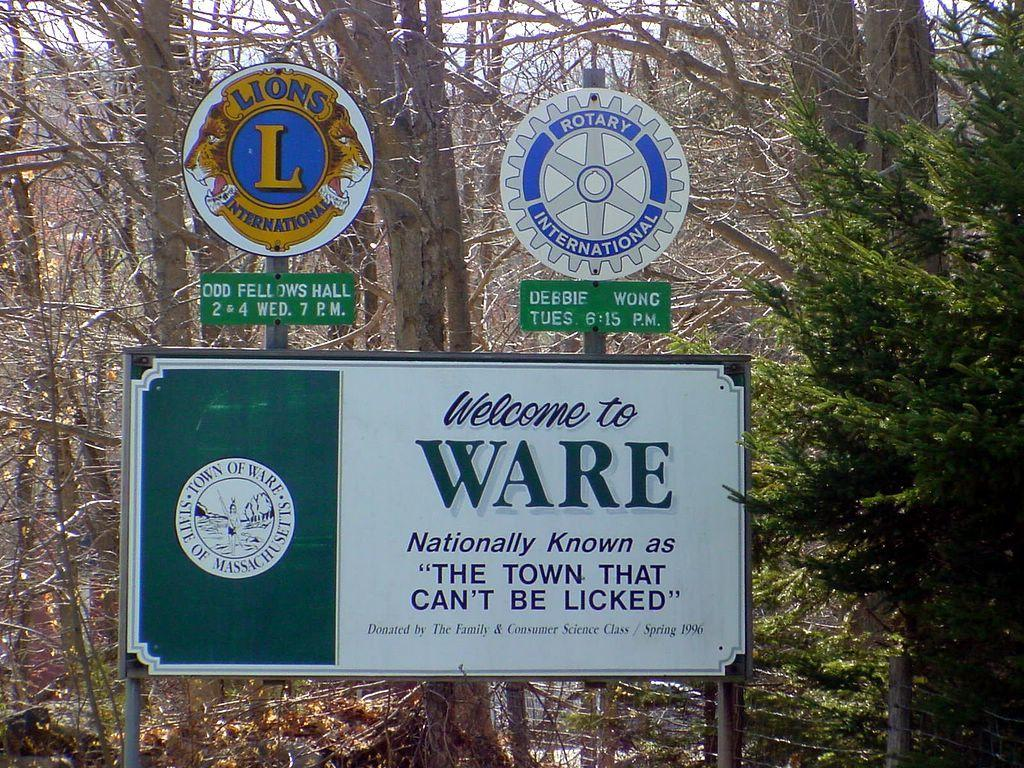<image>
Create a compact narrative representing the image presented. The welcome to Ware sign is in the state of Massachusetts. 